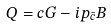Convert formula to latex. <formula><loc_0><loc_0><loc_500><loc_500>Q = c G - i p _ { \bar { c } } B</formula> 